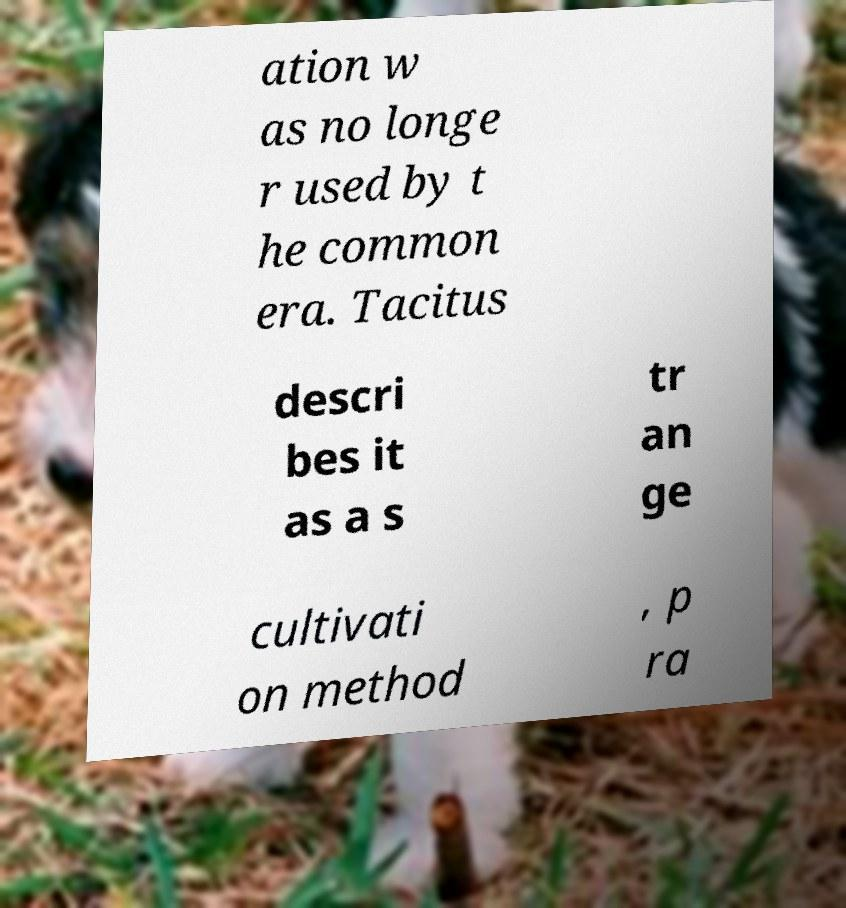Could you assist in decoding the text presented in this image and type it out clearly? ation w as no longe r used by t he common era. Tacitus descri bes it as a s tr an ge cultivati on method , p ra 